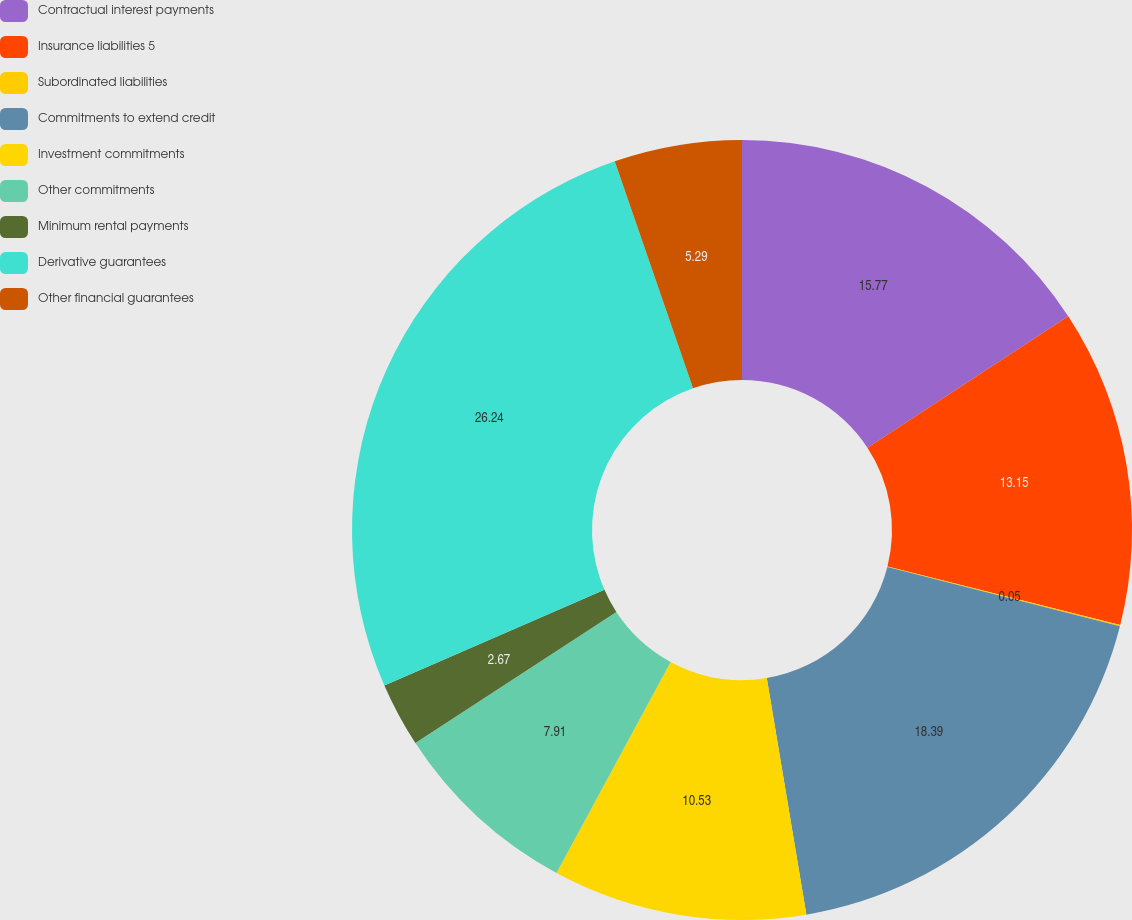<chart> <loc_0><loc_0><loc_500><loc_500><pie_chart><fcel>Contractual interest payments<fcel>Insurance liabilities 5<fcel>Subordinated liabilities<fcel>Commitments to extend credit<fcel>Investment commitments<fcel>Other commitments<fcel>Minimum rental payments<fcel>Derivative guarantees<fcel>Other financial guarantees<nl><fcel>15.77%<fcel>13.15%<fcel>0.05%<fcel>18.39%<fcel>10.53%<fcel>7.91%<fcel>2.67%<fcel>26.24%<fcel>5.29%<nl></chart> 